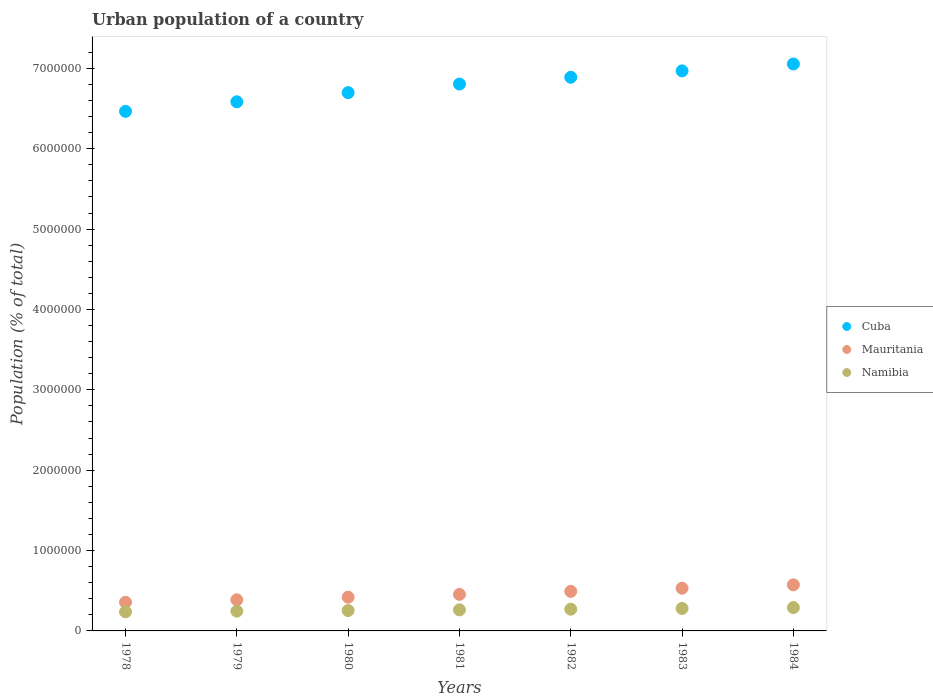What is the urban population in Cuba in 1984?
Ensure brevity in your answer.  7.06e+06. Across all years, what is the maximum urban population in Namibia?
Keep it short and to the point. 2.90e+05. Across all years, what is the minimum urban population in Cuba?
Offer a very short reply. 6.47e+06. In which year was the urban population in Cuba minimum?
Your response must be concise. 1978. What is the total urban population in Cuba in the graph?
Make the answer very short. 4.75e+07. What is the difference between the urban population in Mauritania in 1982 and that in 1983?
Your response must be concise. -3.97e+04. What is the difference between the urban population in Mauritania in 1980 and the urban population in Cuba in 1982?
Offer a very short reply. -6.47e+06. What is the average urban population in Cuba per year?
Your answer should be very brief. 6.78e+06. In the year 1983, what is the difference between the urban population in Mauritania and urban population in Cuba?
Make the answer very short. -6.44e+06. In how many years, is the urban population in Cuba greater than 1600000 %?
Your answer should be compact. 7. What is the ratio of the urban population in Cuba in 1978 to that in 1982?
Give a very brief answer. 0.94. Is the difference between the urban population in Mauritania in 1980 and 1984 greater than the difference between the urban population in Cuba in 1980 and 1984?
Provide a short and direct response. Yes. What is the difference between the highest and the second highest urban population in Cuba?
Ensure brevity in your answer.  8.61e+04. What is the difference between the highest and the lowest urban population in Mauritania?
Make the answer very short. 2.17e+05. In how many years, is the urban population in Cuba greater than the average urban population in Cuba taken over all years?
Ensure brevity in your answer.  4. Is the sum of the urban population in Cuba in 1980 and 1981 greater than the maximum urban population in Mauritania across all years?
Provide a short and direct response. Yes. How many years are there in the graph?
Provide a short and direct response. 7. What is the difference between two consecutive major ticks on the Y-axis?
Provide a short and direct response. 1.00e+06. Does the graph contain any zero values?
Make the answer very short. No. Where does the legend appear in the graph?
Your answer should be very brief. Center right. How are the legend labels stacked?
Offer a terse response. Vertical. What is the title of the graph?
Make the answer very short. Urban population of a country. Does "Slovenia" appear as one of the legend labels in the graph?
Keep it short and to the point. No. What is the label or title of the Y-axis?
Keep it short and to the point. Population (% of total). What is the Population (% of total) in Cuba in 1978?
Ensure brevity in your answer.  6.47e+06. What is the Population (% of total) of Mauritania in 1978?
Provide a succinct answer. 3.57e+05. What is the Population (% of total) in Namibia in 1978?
Ensure brevity in your answer.  2.38e+05. What is the Population (% of total) in Cuba in 1979?
Make the answer very short. 6.58e+06. What is the Population (% of total) in Mauritania in 1979?
Offer a terse response. 3.87e+05. What is the Population (% of total) in Namibia in 1979?
Ensure brevity in your answer.  2.46e+05. What is the Population (% of total) of Cuba in 1980?
Offer a terse response. 6.70e+06. What is the Population (% of total) in Mauritania in 1980?
Offer a terse response. 4.20e+05. What is the Population (% of total) in Namibia in 1980?
Provide a succinct answer. 2.54e+05. What is the Population (% of total) of Cuba in 1981?
Give a very brief answer. 6.81e+06. What is the Population (% of total) of Mauritania in 1981?
Offer a terse response. 4.55e+05. What is the Population (% of total) of Namibia in 1981?
Your answer should be compact. 2.62e+05. What is the Population (% of total) of Cuba in 1982?
Give a very brief answer. 6.89e+06. What is the Population (% of total) of Mauritania in 1982?
Your answer should be compact. 4.92e+05. What is the Population (% of total) of Namibia in 1982?
Your response must be concise. 2.71e+05. What is the Population (% of total) in Cuba in 1983?
Make the answer very short. 6.97e+06. What is the Population (% of total) of Mauritania in 1983?
Your answer should be compact. 5.32e+05. What is the Population (% of total) in Namibia in 1983?
Your answer should be compact. 2.80e+05. What is the Population (% of total) of Cuba in 1984?
Keep it short and to the point. 7.06e+06. What is the Population (% of total) in Mauritania in 1984?
Keep it short and to the point. 5.74e+05. What is the Population (% of total) in Namibia in 1984?
Keep it short and to the point. 2.90e+05. Across all years, what is the maximum Population (% of total) in Cuba?
Offer a very short reply. 7.06e+06. Across all years, what is the maximum Population (% of total) of Mauritania?
Your answer should be very brief. 5.74e+05. Across all years, what is the maximum Population (% of total) in Namibia?
Offer a terse response. 2.90e+05. Across all years, what is the minimum Population (% of total) in Cuba?
Offer a very short reply. 6.47e+06. Across all years, what is the minimum Population (% of total) of Mauritania?
Offer a very short reply. 3.57e+05. Across all years, what is the minimum Population (% of total) of Namibia?
Offer a terse response. 2.38e+05. What is the total Population (% of total) of Cuba in the graph?
Your answer should be compact. 4.75e+07. What is the total Population (% of total) of Mauritania in the graph?
Your answer should be compact. 3.22e+06. What is the total Population (% of total) in Namibia in the graph?
Offer a terse response. 1.84e+06. What is the difference between the Population (% of total) in Cuba in 1978 and that in 1979?
Provide a short and direct response. -1.19e+05. What is the difference between the Population (% of total) in Mauritania in 1978 and that in 1979?
Ensure brevity in your answer.  -3.05e+04. What is the difference between the Population (% of total) of Namibia in 1978 and that in 1979?
Make the answer very short. -7919. What is the difference between the Population (% of total) of Cuba in 1978 and that in 1980?
Give a very brief answer. -2.33e+05. What is the difference between the Population (% of total) in Mauritania in 1978 and that in 1980?
Provide a short and direct response. -6.31e+04. What is the difference between the Population (% of total) in Namibia in 1978 and that in 1980?
Your response must be concise. -1.61e+04. What is the difference between the Population (% of total) in Cuba in 1978 and that in 1981?
Offer a terse response. -3.40e+05. What is the difference between the Population (% of total) in Mauritania in 1978 and that in 1981?
Your response must be concise. -9.80e+04. What is the difference between the Population (% of total) in Namibia in 1978 and that in 1981?
Provide a short and direct response. -2.46e+04. What is the difference between the Population (% of total) in Cuba in 1978 and that in 1982?
Give a very brief answer. -4.24e+05. What is the difference between the Population (% of total) in Mauritania in 1978 and that in 1982?
Give a very brief answer. -1.35e+05. What is the difference between the Population (% of total) of Namibia in 1978 and that in 1982?
Make the answer very short. -3.29e+04. What is the difference between the Population (% of total) in Cuba in 1978 and that in 1983?
Your answer should be very brief. -5.03e+05. What is the difference between the Population (% of total) of Mauritania in 1978 and that in 1983?
Keep it short and to the point. -1.75e+05. What is the difference between the Population (% of total) in Namibia in 1978 and that in 1983?
Ensure brevity in your answer.  -4.20e+04. What is the difference between the Population (% of total) of Cuba in 1978 and that in 1984?
Ensure brevity in your answer.  -5.90e+05. What is the difference between the Population (% of total) in Mauritania in 1978 and that in 1984?
Keep it short and to the point. -2.17e+05. What is the difference between the Population (% of total) in Namibia in 1978 and that in 1984?
Offer a very short reply. -5.27e+04. What is the difference between the Population (% of total) of Cuba in 1979 and that in 1980?
Give a very brief answer. -1.14e+05. What is the difference between the Population (% of total) in Mauritania in 1979 and that in 1980?
Your answer should be compact. -3.27e+04. What is the difference between the Population (% of total) of Namibia in 1979 and that in 1980?
Provide a short and direct response. -8219. What is the difference between the Population (% of total) in Cuba in 1979 and that in 1981?
Provide a succinct answer. -2.21e+05. What is the difference between the Population (% of total) in Mauritania in 1979 and that in 1981?
Your answer should be very brief. -6.76e+04. What is the difference between the Population (% of total) of Namibia in 1979 and that in 1981?
Your answer should be very brief. -1.66e+04. What is the difference between the Population (% of total) in Cuba in 1979 and that in 1982?
Your response must be concise. -3.05e+05. What is the difference between the Population (% of total) of Mauritania in 1979 and that in 1982?
Offer a very short reply. -1.05e+05. What is the difference between the Population (% of total) in Namibia in 1979 and that in 1982?
Provide a succinct answer. -2.50e+04. What is the difference between the Population (% of total) in Cuba in 1979 and that in 1983?
Make the answer very short. -3.85e+05. What is the difference between the Population (% of total) of Mauritania in 1979 and that in 1983?
Provide a succinct answer. -1.45e+05. What is the difference between the Population (% of total) in Namibia in 1979 and that in 1983?
Your response must be concise. -3.41e+04. What is the difference between the Population (% of total) in Cuba in 1979 and that in 1984?
Provide a succinct answer. -4.71e+05. What is the difference between the Population (% of total) of Mauritania in 1979 and that in 1984?
Offer a terse response. -1.87e+05. What is the difference between the Population (% of total) in Namibia in 1979 and that in 1984?
Your answer should be very brief. -4.47e+04. What is the difference between the Population (% of total) of Cuba in 1980 and that in 1981?
Your answer should be compact. -1.07e+05. What is the difference between the Population (% of total) in Mauritania in 1980 and that in 1981?
Give a very brief answer. -3.49e+04. What is the difference between the Population (% of total) of Namibia in 1980 and that in 1981?
Make the answer very short. -8425. What is the difference between the Population (% of total) of Cuba in 1980 and that in 1982?
Provide a succinct answer. -1.91e+05. What is the difference between the Population (% of total) of Mauritania in 1980 and that in 1982?
Offer a terse response. -7.22e+04. What is the difference between the Population (% of total) of Namibia in 1980 and that in 1982?
Make the answer very short. -1.68e+04. What is the difference between the Population (% of total) in Cuba in 1980 and that in 1983?
Offer a terse response. -2.71e+05. What is the difference between the Population (% of total) in Mauritania in 1980 and that in 1983?
Your response must be concise. -1.12e+05. What is the difference between the Population (% of total) in Namibia in 1980 and that in 1983?
Your answer should be very brief. -2.59e+04. What is the difference between the Population (% of total) of Cuba in 1980 and that in 1984?
Offer a terse response. -3.57e+05. What is the difference between the Population (% of total) in Mauritania in 1980 and that in 1984?
Ensure brevity in your answer.  -1.54e+05. What is the difference between the Population (% of total) of Namibia in 1980 and that in 1984?
Ensure brevity in your answer.  -3.65e+04. What is the difference between the Population (% of total) in Cuba in 1981 and that in 1982?
Keep it short and to the point. -8.42e+04. What is the difference between the Population (% of total) of Mauritania in 1981 and that in 1982?
Give a very brief answer. -3.73e+04. What is the difference between the Population (% of total) in Namibia in 1981 and that in 1982?
Your answer should be compact. -8362. What is the difference between the Population (% of total) in Cuba in 1981 and that in 1983?
Make the answer very short. -1.64e+05. What is the difference between the Population (% of total) in Mauritania in 1981 and that in 1983?
Give a very brief answer. -7.70e+04. What is the difference between the Population (% of total) of Namibia in 1981 and that in 1983?
Your answer should be very brief. -1.75e+04. What is the difference between the Population (% of total) in Cuba in 1981 and that in 1984?
Offer a terse response. -2.50e+05. What is the difference between the Population (% of total) in Mauritania in 1981 and that in 1984?
Your answer should be compact. -1.19e+05. What is the difference between the Population (% of total) of Namibia in 1981 and that in 1984?
Make the answer very short. -2.81e+04. What is the difference between the Population (% of total) in Cuba in 1982 and that in 1983?
Make the answer very short. -7.95e+04. What is the difference between the Population (% of total) in Mauritania in 1982 and that in 1983?
Your answer should be very brief. -3.97e+04. What is the difference between the Population (% of total) of Namibia in 1982 and that in 1983?
Your answer should be compact. -9103. What is the difference between the Population (% of total) in Cuba in 1982 and that in 1984?
Provide a short and direct response. -1.66e+05. What is the difference between the Population (% of total) of Mauritania in 1982 and that in 1984?
Keep it short and to the point. -8.18e+04. What is the difference between the Population (% of total) in Namibia in 1982 and that in 1984?
Give a very brief answer. -1.97e+04. What is the difference between the Population (% of total) in Cuba in 1983 and that in 1984?
Your answer should be very brief. -8.61e+04. What is the difference between the Population (% of total) of Mauritania in 1983 and that in 1984?
Provide a succinct answer. -4.21e+04. What is the difference between the Population (% of total) of Namibia in 1983 and that in 1984?
Offer a terse response. -1.06e+04. What is the difference between the Population (% of total) in Cuba in 1978 and the Population (% of total) in Mauritania in 1979?
Provide a succinct answer. 6.08e+06. What is the difference between the Population (% of total) in Cuba in 1978 and the Population (% of total) in Namibia in 1979?
Ensure brevity in your answer.  6.22e+06. What is the difference between the Population (% of total) in Mauritania in 1978 and the Population (% of total) in Namibia in 1979?
Make the answer very short. 1.11e+05. What is the difference between the Population (% of total) of Cuba in 1978 and the Population (% of total) of Mauritania in 1980?
Give a very brief answer. 6.05e+06. What is the difference between the Population (% of total) in Cuba in 1978 and the Population (% of total) in Namibia in 1980?
Keep it short and to the point. 6.21e+06. What is the difference between the Population (% of total) of Mauritania in 1978 and the Population (% of total) of Namibia in 1980?
Your answer should be compact. 1.03e+05. What is the difference between the Population (% of total) of Cuba in 1978 and the Population (% of total) of Mauritania in 1981?
Ensure brevity in your answer.  6.01e+06. What is the difference between the Population (% of total) in Cuba in 1978 and the Population (% of total) in Namibia in 1981?
Offer a terse response. 6.20e+06. What is the difference between the Population (% of total) of Mauritania in 1978 and the Population (% of total) of Namibia in 1981?
Give a very brief answer. 9.45e+04. What is the difference between the Population (% of total) in Cuba in 1978 and the Population (% of total) in Mauritania in 1982?
Your answer should be compact. 5.97e+06. What is the difference between the Population (% of total) in Cuba in 1978 and the Population (% of total) in Namibia in 1982?
Provide a succinct answer. 6.20e+06. What is the difference between the Population (% of total) in Mauritania in 1978 and the Population (% of total) in Namibia in 1982?
Provide a succinct answer. 8.61e+04. What is the difference between the Population (% of total) in Cuba in 1978 and the Population (% of total) in Mauritania in 1983?
Provide a succinct answer. 5.93e+06. What is the difference between the Population (% of total) of Cuba in 1978 and the Population (% of total) of Namibia in 1983?
Your answer should be very brief. 6.19e+06. What is the difference between the Population (% of total) in Mauritania in 1978 and the Population (% of total) in Namibia in 1983?
Make the answer very short. 7.70e+04. What is the difference between the Population (% of total) in Cuba in 1978 and the Population (% of total) in Mauritania in 1984?
Make the answer very short. 5.89e+06. What is the difference between the Population (% of total) of Cuba in 1978 and the Population (% of total) of Namibia in 1984?
Give a very brief answer. 6.18e+06. What is the difference between the Population (% of total) in Mauritania in 1978 and the Population (% of total) in Namibia in 1984?
Offer a very short reply. 6.64e+04. What is the difference between the Population (% of total) in Cuba in 1979 and the Population (% of total) in Mauritania in 1980?
Your answer should be compact. 6.16e+06. What is the difference between the Population (% of total) in Cuba in 1979 and the Population (% of total) in Namibia in 1980?
Provide a succinct answer. 6.33e+06. What is the difference between the Population (% of total) of Mauritania in 1979 and the Population (% of total) of Namibia in 1980?
Offer a terse response. 1.33e+05. What is the difference between the Population (% of total) of Cuba in 1979 and the Population (% of total) of Mauritania in 1981?
Offer a very short reply. 6.13e+06. What is the difference between the Population (% of total) in Cuba in 1979 and the Population (% of total) in Namibia in 1981?
Offer a very short reply. 6.32e+06. What is the difference between the Population (% of total) in Mauritania in 1979 and the Population (% of total) in Namibia in 1981?
Give a very brief answer. 1.25e+05. What is the difference between the Population (% of total) of Cuba in 1979 and the Population (% of total) of Mauritania in 1982?
Make the answer very short. 6.09e+06. What is the difference between the Population (% of total) of Cuba in 1979 and the Population (% of total) of Namibia in 1982?
Your answer should be very brief. 6.31e+06. What is the difference between the Population (% of total) in Mauritania in 1979 and the Population (% of total) in Namibia in 1982?
Offer a terse response. 1.17e+05. What is the difference between the Population (% of total) in Cuba in 1979 and the Population (% of total) in Mauritania in 1983?
Keep it short and to the point. 6.05e+06. What is the difference between the Population (% of total) in Cuba in 1979 and the Population (% of total) in Namibia in 1983?
Make the answer very short. 6.30e+06. What is the difference between the Population (% of total) of Mauritania in 1979 and the Population (% of total) of Namibia in 1983?
Your answer should be compact. 1.07e+05. What is the difference between the Population (% of total) in Cuba in 1979 and the Population (% of total) in Mauritania in 1984?
Provide a succinct answer. 6.01e+06. What is the difference between the Population (% of total) of Cuba in 1979 and the Population (% of total) of Namibia in 1984?
Your answer should be compact. 6.29e+06. What is the difference between the Population (% of total) of Mauritania in 1979 and the Population (% of total) of Namibia in 1984?
Provide a succinct answer. 9.68e+04. What is the difference between the Population (% of total) in Cuba in 1980 and the Population (% of total) in Mauritania in 1981?
Offer a terse response. 6.24e+06. What is the difference between the Population (% of total) of Cuba in 1980 and the Population (% of total) of Namibia in 1981?
Ensure brevity in your answer.  6.44e+06. What is the difference between the Population (% of total) in Mauritania in 1980 and the Population (% of total) in Namibia in 1981?
Ensure brevity in your answer.  1.58e+05. What is the difference between the Population (% of total) in Cuba in 1980 and the Population (% of total) in Mauritania in 1982?
Provide a succinct answer. 6.21e+06. What is the difference between the Population (% of total) of Cuba in 1980 and the Population (% of total) of Namibia in 1982?
Offer a terse response. 6.43e+06. What is the difference between the Population (% of total) in Mauritania in 1980 and the Population (% of total) in Namibia in 1982?
Make the answer very short. 1.49e+05. What is the difference between the Population (% of total) of Cuba in 1980 and the Population (% of total) of Mauritania in 1983?
Ensure brevity in your answer.  6.17e+06. What is the difference between the Population (% of total) of Cuba in 1980 and the Population (% of total) of Namibia in 1983?
Give a very brief answer. 6.42e+06. What is the difference between the Population (% of total) of Mauritania in 1980 and the Population (% of total) of Namibia in 1983?
Provide a succinct answer. 1.40e+05. What is the difference between the Population (% of total) in Cuba in 1980 and the Population (% of total) in Mauritania in 1984?
Offer a terse response. 6.12e+06. What is the difference between the Population (% of total) of Cuba in 1980 and the Population (% of total) of Namibia in 1984?
Give a very brief answer. 6.41e+06. What is the difference between the Population (% of total) of Mauritania in 1980 and the Population (% of total) of Namibia in 1984?
Offer a very short reply. 1.30e+05. What is the difference between the Population (% of total) of Cuba in 1981 and the Population (% of total) of Mauritania in 1982?
Offer a terse response. 6.31e+06. What is the difference between the Population (% of total) in Cuba in 1981 and the Population (% of total) in Namibia in 1982?
Offer a very short reply. 6.53e+06. What is the difference between the Population (% of total) in Mauritania in 1981 and the Population (% of total) in Namibia in 1982?
Provide a short and direct response. 1.84e+05. What is the difference between the Population (% of total) of Cuba in 1981 and the Population (% of total) of Mauritania in 1983?
Provide a succinct answer. 6.27e+06. What is the difference between the Population (% of total) of Cuba in 1981 and the Population (% of total) of Namibia in 1983?
Your response must be concise. 6.53e+06. What is the difference between the Population (% of total) of Mauritania in 1981 and the Population (% of total) of Namibia in 1983?
Offer a terse response. 1.75e+05. What is the difference between the Population (% of total) in Cuba in 1981 and the Population (% of total) in Mauritania in 1984?
Ensure brevity in your answer.  6.23e+06. What is the difference between the Population (% of total) in Cuba in 1981 and the Population (% of total) in Namibia in 1984?
Your response must be concise. 6.52e+06. What is the difference between the Population (% of total) of Mauritania in 1981 and the Population (% of total) of Namibia in 1984?
Make the answer very short. 1.64e+05. What is the difference between the Population (% of total) of Cuba in 1982 and the Population (% of total) of Mauritania in 1983?
Ensure brevity in your answer.  6.36e+06. What is the difference between the Population (% of total) of Cuba in 1982 and the Population (% of total) of Namibia in 1983?
Make the answer very short. 6.61e+06. What is the difference between the Population (% of total) of Mauritania in 1982 and the Population (% of total) of Namibia in 1983?
Keep it short and to the point. 2.12e+05. What is the difference between the Population (% of total) of Cuba in 1982 and the Population (% of total) of Mauritania in 1984?
Offer a terse response. 6.32e+06. What is the difference between the Population (% of total) in Cuba in 1982 and the Population (% of total) in Namibia in 1984?
Provide a succinct answer. 6.60e+06. What is the difference between the Population (% of total) in Mauritania in 1982 and the Population (% of total) in Namibia in 1984?
Provide a succinct answer. 2.02e+05. What is the difference between the Population (% of total) in Cuba in 1983 and the Population (% of total) in Mauritania in 1984?
Offer a terse response. 6.40e+06. What is the difference between the Population (% of total) of Cuba in 1983 and the Population (% of total) of Namibia in 1984?
Provide a succinct answer. 6.68e+06. What is the difference between the Population (% of total) of Mauritania in 1983 and the Population (% of total) of Namibia in 1984?
Offer a very short reply. 2.41e+05. What is the average Population (% of total) in Cuba per year?
Keep it short and to the point. 6.78e+06. What is the average Population (% of total) in Mauritania per year?
Your answer should be compact. 4.59e+05. What is the average Population (% of total) of Namibia per year?
Provide a succinct answer. 2.63e+05. In the year 1978, what is the difference between the Population (% of total) in Cuba and Population (% of total) in Mauritania?
Provide a short and direct response. 6.11e+06. In the year 1978, what is the difference between the Population (% of total) in Cuba and Population (% of total) in Namibia?
Your answer should be very brief. 6.23e+06. In the year 1978, what is the difference between the Population (% of total) of Mauritania and Population (% of total) of Namibia?
Offer a very short reply. 1.19e+05. In the year 1979, what is the difference between the Population (% of total) in Cuba and Population (% of total) in Mauritania?
Make the answer very short. 6.20e+06. In the year 1979, what is the difference between the Population (% of total) in Cuba and Population (% of total) in Namibia?
Your response must be concise. 6.34e+06. In the year 1979, what is the difference between the Population (% of total) in Mauritania and Population (% of total) in Namibia?
Provide a succinct answer. 1.42e+05. In the year 1980, what is the difference between the Population (% of total) in Cuba and Population (% of total) in Mauritania?
Make the answer very short. 6.28e+06. In the year 1980, what is the difference between the Population (% of total) of Cuba and Population (% of total) of Namibia?
Make the answer very short. 6.44e+06. In the year 1980, what is the difference between the Population (% of total) of Mauritania and Population (% of total) of Namibia?
Your response must be concise. 1.66e+05. In the year 1981, what is the difference between the Population (% of total) of Cuba and Population (% of total) of Mauritania?
Make the answer very short. 6.35e+06. In the year 1981, what is the difference between the Population (% of total) in Cuba and Population (% of total) in Namibia?
Offer a very short reply. 6.54e+06. In the year 1981, what is the difference between the Population (% of total) of Mauritania and Population (% of total) of Namibia?
Offer a terse response. 1.93e+05. In the year 1982, what is the difference between the Population (% of total) of Cuba and Population (% of total) of Mauritania?
Offer a very short reply. 6.40e+06. In the year 1982, what is the difference between the Population (% of total) of Cuba and Population (% of total) of Namibia?
Give a very brief answer. 6.62e+06. In the year 1982, what is the difference between the Population (% of total) in Mauritania and Population (% of total) in Namibia?
Keep it short and to the point. 2.21e+05. In the year 1983, what is the difference between the Population (% of total) in Cuba and Population (% of total) in Mauritania?
Provide a short and direct response. 6.44e+06. In the year 1983, what is the difference between the Population (% of total) in Cuba and Population (% of total) in Namibia?
Your answer should be very brief. 6.69e+06. In the year 1983, what is the difference between the Population (% of total) in Mauritania and Population (% of total) in Namibia?
Give a very brief answer. 2.52e+05. In the year 1984, what is the difference between the Population (% of total) of Cuba and Population (% of total) of Mauritania?
Your answer should be compact. 6.48e+06. In the year 1984, what is the difference between the Population (% of total) of Cuba and Population (% of total) of Namibia?
Offer a very short reply. 6.76e+06. In the year 1984, what is the difference between the Population (% of total) in Mauritania and Population (% of total) in Namibia?
Make the answer very short. 2.83e+05. What is the ratio of the Population (% of total) of Cuba in 1978 to that in 1979?
Ensure brevity in your answer.  0.98. What is the ratio of the Population (% of total) in Mauritania in 1978 to that in 1979?
Offer a terse response. 0.92. What is the ratio of the Population (% of total) in Namibia in 1978 to that in 1979?
Give a very brief answer. 0.97. What is the ratio of the Population (% of total) of Cuba in 1978 to that in 1980?
Offer a very short reply. 0.97. What is the ratio of the Population (% of total) in Mauritania in 1978 to that in 1980?
Your answer should be very brief. 0.85. What is the ratio of the Population (% of total) of Namibia in 1978 to that in 1980?
Your response must be concise. 0.94. What is the ratio of the Population (% of total) in Cuba in 1978 to that in 1981?
Provide a short and direct response. 0.95. What is the ratio of the Population (% of total) of Mauritania in 1978 to that in 1981?
Provide a short and direct response. 0.78. What is the ratio of the Population (% of total) in Namibia in 1978 to that in 1981?
Offer a very short reply. 0.91. What is the ratio of the Population (% of total) of Cuba in 1978 to that in 1982?
Ensure brevity in your answer.  0.94. What is the ratio of the Population (% of total) in Mauritania in 1978 to that in 1982?
Ensure brevity in your answer.  0.72. What is the ratio of the Population (% of total) of Namibia in 1978 to that in 1982?
Provide a short and direct response. 0.88. What is the ratio of the Population (% of total) of Cuba in 1978 to that in 1983?
Offer a very short reply. 0.93. What is the ratio of the Population (% of total) in Mauritania in 1978 to that in 1983?
Offer a terse response. 0.67. What is the ratio of the Population (% of total) of Namibia in 1978 to that in 1983?
Your answer should be very brief. 0.85. What is the ratio of the Population (% of total) of Cuba in 1978 to that in 1984?
Provide a short and direct response. 0.92. What is the ratio of the Population (% of total) of Mauritania in 1978 to that in 1984?
Offer a very short reply. 0.62. What is the ratio of the Population (% of total) of Namibia in 1978 to that in 1984?
Ensure brevity in your answer.  0.82. What is the ratio of the Population (% of total) in Cuba in 1979 to that in 1980?
Provide a short and direct response. 0.98. What is the ratio of the Population (% of total) of Mauritania in 1979 to that in 1980?
Your answer should be compact. 0.92. What is the ratio of the Population (% of total) in Namibia in 1979 to that in 1980?
Your response must be concise. 0.97. What is the ratio of the Population (% of total) in Cuba in 1979 to that in 1981?
Keep it short and to the point. 0.97. What is the ratio of the Population (% of total) in Mauritania in 1979 to that in 1981?
Keep it short and to the point. 0.85. What is the ratio of the Population (% of total) in Namibia in 1979 to that in 1981?
Offer a terse response. 0.94. What is the ratio of the Population (% of total) of Cuba in 1979 to that in 1982?
Your answer should be compact. 0.96. What is the ratio of the Population (% of total) of Mauritania in 1979 to that in 1982?
Give a very brief answer. 0.79. What is the ratio of the Population (% of total) of Namibia in 1979 to that in 1982?
Provide a short and direct response. 0.91. What is the ratio of the Population (% of total) of Cuba in 1979 to that in 1983?
Make the answer very short. 0.94. What is the ratio of the Population (% of total) in Mauritania in 1979 to that in 1983?
Your response must be concise. 0.73. What is the ratio of the Population (% of total) of Namibia in 1979 to that in 1983?
Provide a short and direct response. 0.88. What is the ratio of the Population (% of total) in Cuba in 1979 to that in 1984?
Give a very brief answer. 0.93. What is the ratio of the Population (% of total) in Mauritania in 1979 to that in 1984?
Your answer should be very brief. 0.67. What is the ratio of the Population (% of total) in Namibia in 1979 to that in 1984?
Provide a succinct answer. 0.85. What is the ratio of the Population (% of total) in Cuba in 1980 to that in 1981?
Ensure brevity in your answer.  0.98. What is the ratio of the Population (% of total) of Mauritania in 1980 to that in 1981?
Keep it short and to the point. 0.92. What is the ratio of the Population (% of total) of Namibia in 1980 to that in 1981?
Your answer should be very brief. 0.97. What is the ratio of the Population (% of total) of Cuba in 1980 to that in 1982?
Provide a short and direct response. 0.97. What is the ratio of the Population (% of total) of Mauritania in 1980 to that in 1982?
Your answer should be very brief. 0.85. What is the ratio of the Population (% of total) of Namibia in 1980 to that in 1982?
Provide a succinct answer. 0.94. What is the ratio of the Population (% of total) in Cuba in 1980 to that in 1983?
Make the answer very short. 0.96. What is the ratio of the Population (% of total) in Mauritania in 1980 to that in 1983?
Your answer should be very brief. 0.79. What is the ratio of the Population (% of total) in Namibia in 1980 to that in 1983?
Your answer should be very brief. 0.91. What is the ratio of the Population (% of total) of Cuba in 1980 to that in 1984?
Provide a short and direct response. 0.95. What is the ratio of the Population (% of total) of Mauritania in 1980 to that in 1984?
Your response must be concise. 0.73. What is the ratio of the Population (% of total) of Namibia in 1980 to that in 1984?
Ensure brevity in your answer.  0.87. What is the ratio of the Population (% of total) in Cuba in 1981 to that in 1982?
Make the answer very short. 0.99. What is the ratio of the Population (% of total) in Mauritania in 1981 to that in 1982?
Offer a very short reply. 0.92. What is the ratio of the Population (% of total) in Namibia in 1981 to that in 1982?
Keep it short and to the point. 0.97. What is the ratio of the Population (% of total) of Cuba in 1981 to that in 1983?
Your response must be concise. 0.98. What is the ratio of the Population (% of total) of Mauritania in 1981 to that in 1983?
Give a very brief answer. 0.86. What is the ratio of the Population (% of total) in Namibia in 1981 to that in 1983?
Provide a succinct answer. 0.94. What is the ratio of the Population (% of total) of Cuba in 1981 to that in 1984?
Keep it short and to the point. 0.96. What is the ratio of the Population (% of total) in Mauritania in 1981 to that in 1984?
Ensure brevity in your answer.  0.79. What is the ratio of the Population (% of total) of Namibia in 1981 to that in 1984?
Provide a succinct answer. 0.9. What is the ratio of the Population (% of total) in Mauritania in 1982 to that in 1983?
Ensure brevity in your answer.  0.93. What is the ratio of the Population (% of total) in Namibia in 1982 to that in 1983?
Provide a short and direct response. 0.97. What is the ratio of the Population (% of total) in Cuba in 1982 to that in 1984?
Give a very brief answer. 0.98. What is the ratio of the Population (% of total) in Mauritania in 1982 to that in 1984?
Offer a terse response. 0.86. What is the ratio of the Population (% of total) of Namibia in 1982 to that in 1984?
Keep it short and to the point. 0.93. What is the ratio of the Population (% of total) in Mauritania in 1983 to that in 1984?
Keep it short and to the point. 0.93. What is the ratio of the Population (% of total) in Namibia in 1983 to that in 1984?
Provide a short and direct response. 0.96. What is the difference between the highest and the second highest Population (% of total) in Cuba?
Give a very brief answer. 8.61e+04. What is the difference between the highest and the second highest Population (% of total) of Mauritania?
Offer a very short reply. 4.21e+04. What is the difference between the highest and the second highest Population (% of total) of Namibia?
Ensure brevity in your answer.  1.06e+04. What is the difference between the highest and the lowest Population (% of total) in Cuba?
Offer a terse response. 5.90e+05. What is the difference between the highest and the lowest Population (% of total) in Mauritania?
Offer a very short reply. 2.17e+05. What is the difference between the highest and the lowest Population (% of total) of Namibia?
Your answer should be compact. 5.27e+04. 